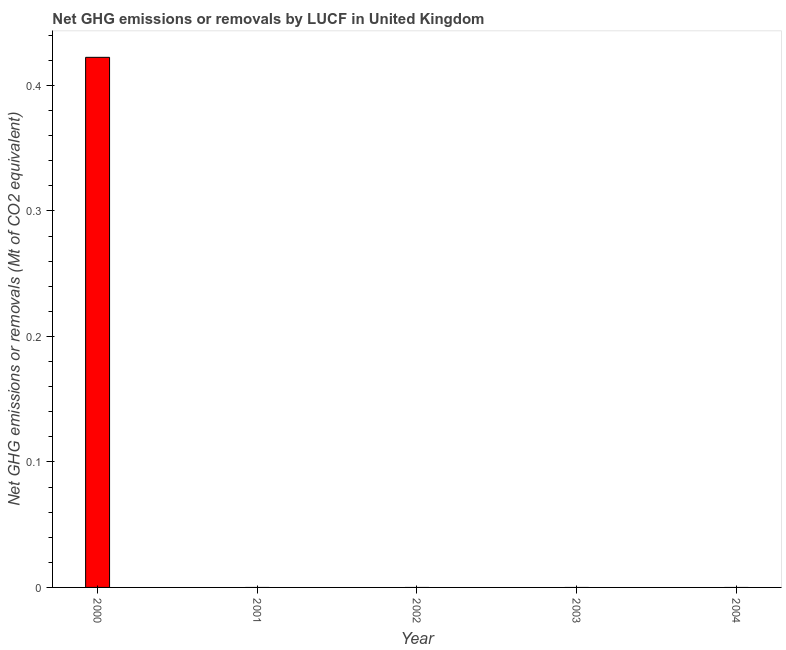Does the graph contain any zero values?
Offer a very short reply. Yes. Does the graph contain grids?
Your answer should be very brief. No. What is the title of the graph?
Your answer should be very brief. Net GHG emissions or removals by LUCF in United Kingdom. What is the label or title of the Y-axis?
Make the answer very short. Net GHG emissions or removals (Mt of CO2 equivalent). Across all years, what is the maximum ghg net emissions or removals?
Provide a succinct answer. 0.42. Across all years, what is the minimum ghg net emissions or removals?
Your answer should be very brief. 0. What is the sum of the ghg net emissions or removals?
Your answer should be very brief. 0.42. What is the average ghg net emissions or removals per year?
Ensure brevity in your answer.  0.08. What is the median ghg net emissions or removals?
Provide a succinct answer. 0. What is the difference between the highest and the lowest ghg net emissions or removals?
Keep it short and to the point. 0.42. How many bars are there?
Your response must be concise. 1. Are all the bars in the graph horizontal?
Give a very brief answer. No. What is the difference between two consecutive major ticks on the Y-axis?
Your answer should be compact. 0.1. What is the Net GHG emissions or removals (Mt of CO2 equivalent) of 2000?
Your answer should be very brief. 0.42. What is the Net GHG emissions or removals (Mt of CO2 equivalent) of 2001?
Provide a succinct answer. 0. What is the Net GHG emissions or removals (Mt of CO2 equivalent) in 2002?
Ensure brevity in your answer.  0. What is the Net GHG emissions or removals (Mt of CO2 equivalent) in 2004?
Offer a very short reply. 0. 